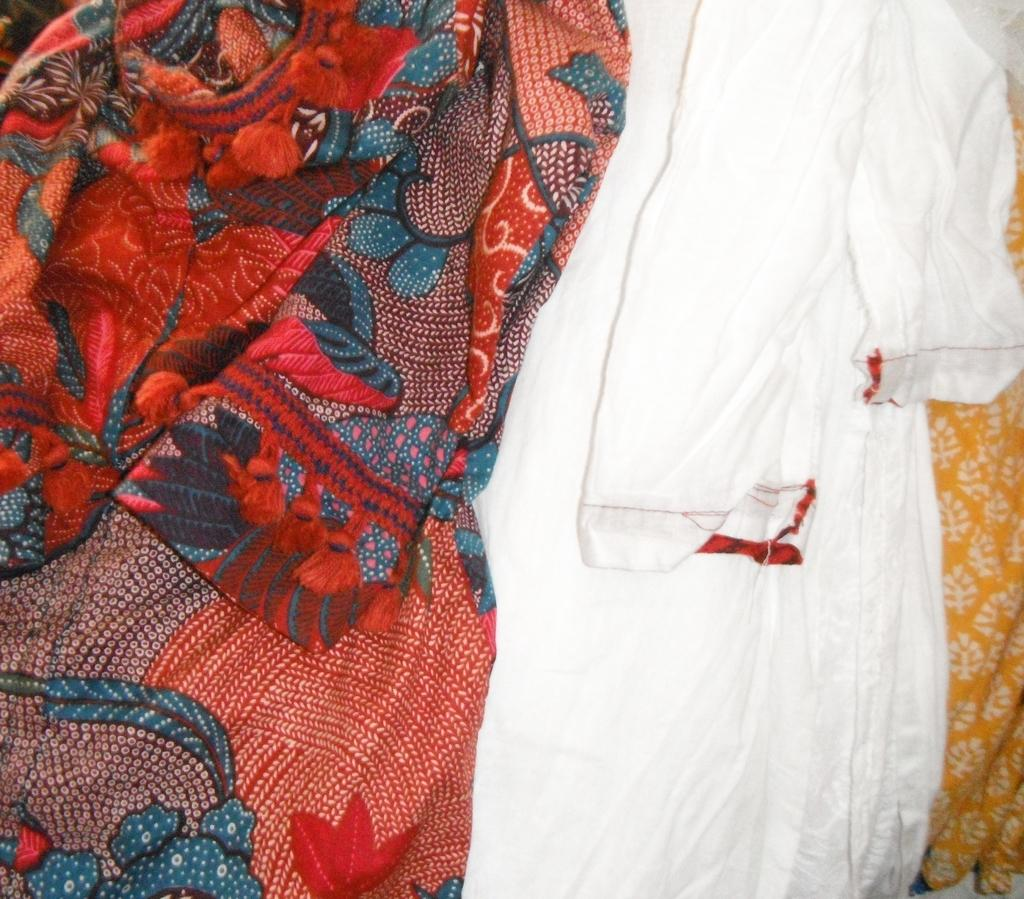What type of items can be seen in the image? There are clothes in the image. Can you describe the white cloth in the image? There is a white color cloth in the image. What is unique about the white cloth? There is a design on the white cloth. What story is being told by the muscle in the image? There is no muscle present in the image, so no story can be told by it. 